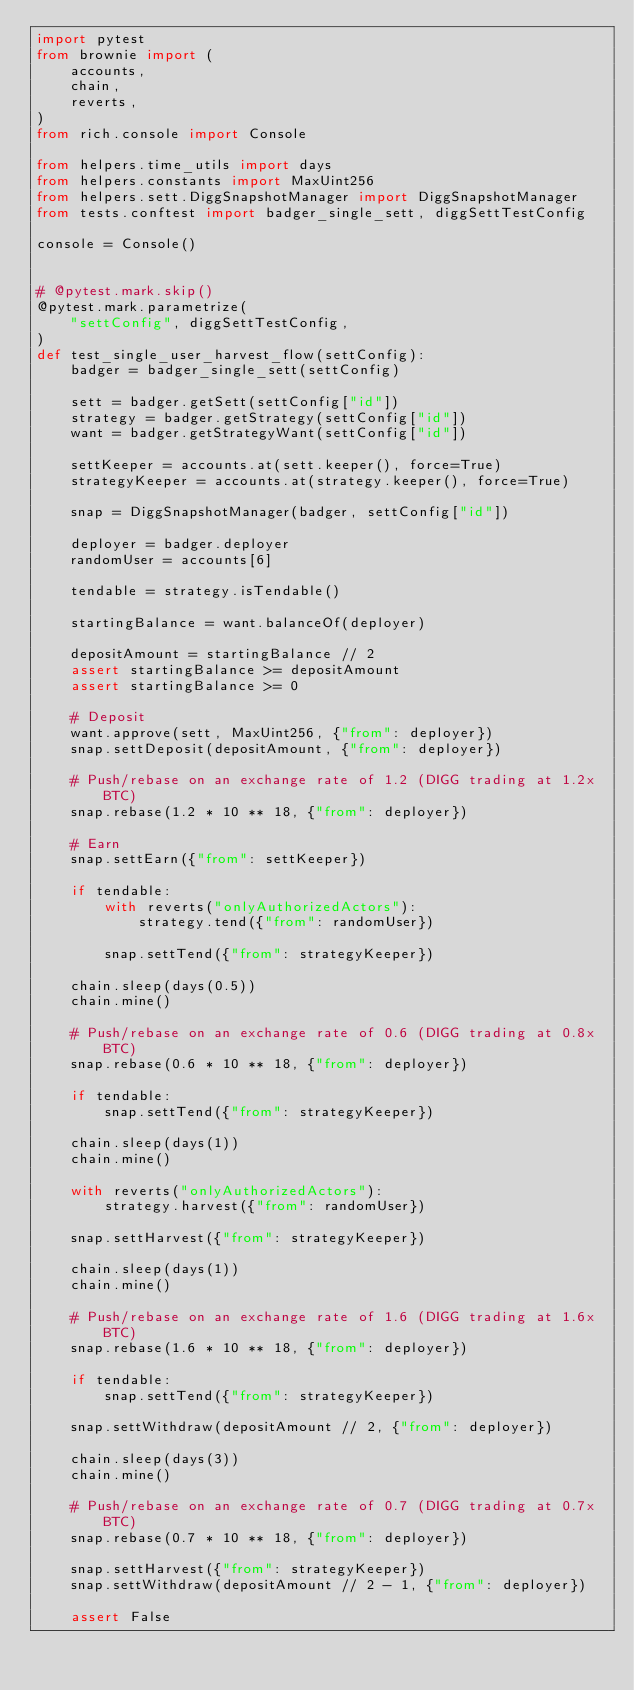<code> <loc_0><loc_0><loc_500><loc_500><_Python_>import pytest
from brownie import (
    accounts,
    chain,
    reverts,
)
from rich.console import Console

from helpers.time_utils import days
from helpers.constants import MaxUint256
from helpers.sett.DiggSnapshotManager import DiggSnapshotManager
from tests.conftest import badger_single_sett, diggSettTestConfig

console = Console()


# @pytest.mark.skip()
@pytest.mark.parametrize(
    "settConfig", diggSettTestConfig,
)
def test_single_user_harvest_flow(settConfig):
    badger = badger_single_sett(settConfig)

    sett = badger.getSett(settConfig["id"])
    strategy = badger.getStrategy(settConfig["id"])
    want = badger.getStrategyWant(settConfig["id"])

    settKeeper = accounts.at(sett.keeper(), force=True)
    strategyKeeper = accounts.at(strategy.keeper(), force=True)

    snap = DiggSnapshotManager(badger, settConfig["id"])

    deployer = badger.deployer
    randomUser = accounts[6]

    tendable = strategy.isTendable()

    startingBalance = want.balanceOf(deployer)

    depositAmount = startingBalance // 2
    assert startingBalance >= depositAmount
    assert startingBalance >= 0

    # Deposit
    want.approve(sett, MaxUint256, {"from": deployer})
    snap.settDeposit(depositAmount, {"from": deployer})

    # Push/rebase on an exchange rate of 1.2 (DIGG trading at 1.2x BTC)
    snap.rebase(1.2 * 10 ** 18, {"from": deployer})

    # Earn
    snap.settEarn({"from": settKeeper})

    if tendable:
        with reverts("onlyAuthorizedActors"):
            strategy.tend({"from": randomUser})

        snap.settTend({"from": strategyKeeper})

    chain.sleep(days(0.5))
    chain.mine()

    # Push/rebase on an exchange rate of 0.6 (DIGG trading at 0.8x BTC)
    snap.rebase(0.6 * 10 ** 18, {"from": deployer})

    if tendable:
        snap.settTend({"from": strategyKeeper})

    chain.sleep(days(1))
    chain.mine()

    with reverts("onlyAuthorizedActors"):
        strategy.harvest({"from": randomUser})

    snap.settHarvest({"from": strategyKeeper})

    chain.sleep(days(1))
    chain.mine()

    # Push/rebase on an exchange rate of 1.6 (DIGG trading at 1.6x BTC)
    snap.rebase(1.6 * 10 ** 18, {"from": deployer})

    if tendable:
        snap.settTend({"from": strategyKeeper})

    snap.settWithdraw(depositAmount // 2, {"from": deployer})

    chain.sleep(days(3))
    chain.mine()

    # Push/rebase on an exchange rate of 0.7 (DIGG trading at 0.7x BTC)
    snap.rebase(0.7 * 10 ** 18, {"from": deployer})

    snap.settHarvest({"from": strategyKeeper})
    snap.settWithdraw(depositAmount // 2 - 1, {"from": deployer})

    assert False
</code> 